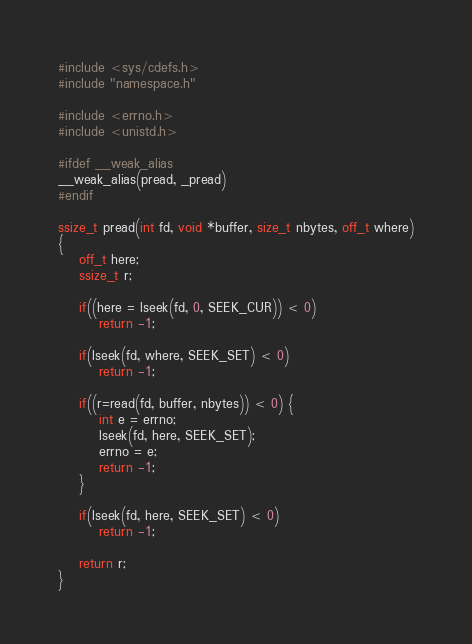Convert code to text. <code><loc_0><loc_0><loc_500><loc_500><_C_>#include <sys/cdefs.h>
#include "namespace.h"

#include <errno.h>
#include <unistd.h>

#ifdef __weak_alias
__weak_alias(pread, _pread)
#endif

ssize_t pread(int fd, void *buffer, size_t nbytes, off_t where)
{
	off_t here;
	ssize_t r;

	if((here = lseek(fd, 0, SEEK_CUR)) < 0)
		return -1;

	if(lseek(fd, where, SEEK_SET) < 0)
		return -1;

	if((r=read(fd, buffer, nbytes)) < 0) {
		int e = errno;
		lseek(fd, here, SEEK_SET);
		errno = e;
		return -1;
	}

	if(lseek(fd, here, SEEK_SET) < 0)
		return -1;

	return r;
}

</code> 